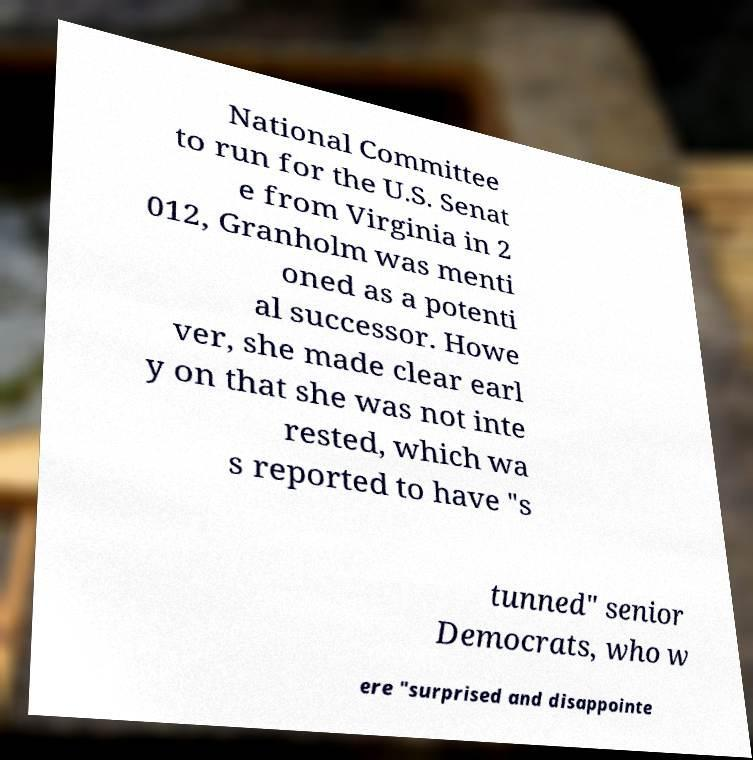For documentation purposes, I need the text within this image transcribed. Could you provide that? National Committee to run for the U.S. Senat e from Virginia in 2 012, Granholm was menti oned as a potenti al successor. Howe ver, she made clear earl y on that she was not inte rested, which wa s reported to have "s tunned" senior Democrats, who w ere "surprised and disappointe 